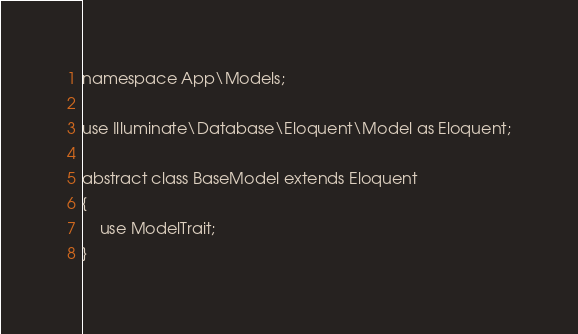Convert code to text. <code><loc_0><loc_0><loc_500><loc_500><_PHP_>namespace App\Models;

use Illuminate\Database\Eloquent\Model as Eloquent;

abstract class BaseModel extends Eloquent
{
    use ModelTrait;
}</code> 